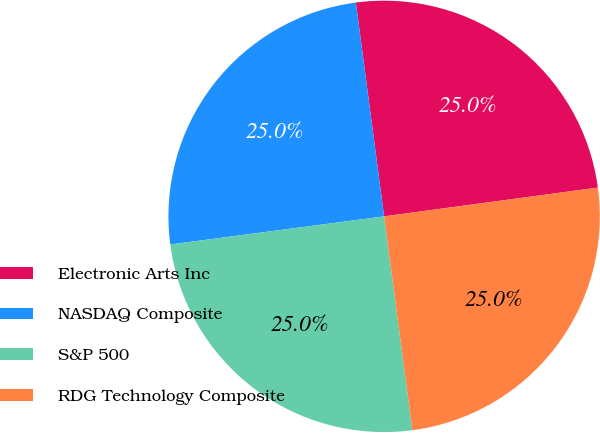Convert chart. <chart><loc_0><loc_0><loc_500><loc_500><pie_chart><fcel>Electronic Arts Inc<fcel>NASDAQ Composite<fcel>S&P 500<fcel>RDG Technology Composite<nl><fcel>24.96%<fcel>24.99%<fcel>25.01%<fcel>25.04%<nl></chart> 